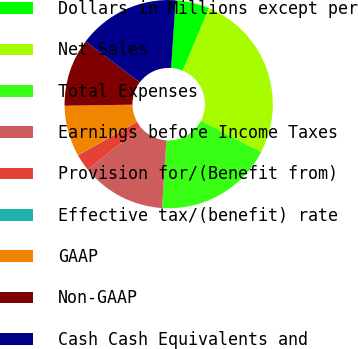Convert chart to OTSL. <chart><loc_0><loc_0><loc_500><loc_500><pie_chart><fcel>Dollars in Millions except per<fcel>Net Sales<fcel>Total Expenses<fcel>Earnings before Income Taxes<fcel>Provision for/(Benefit from)<fcel>Effective tax/(benefit) rate<fcel>GAAP<fcel>Non-GAAP<fcel>Cash Cash Equivalents and<nl><fcel>5.28%<fcel>26.27%<fcel>18.4%<fcel>13.15%<fcel>2.66%<fcel>0.03%<fcel>7.9%<fcel>10.53%<fcel>15.77%<nl></chart> 